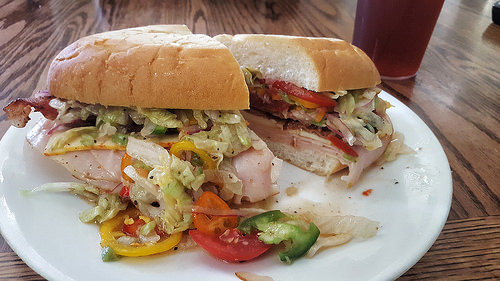<image>
Is the tomato above the meat? Yes. The tomato is positioned above the meat in the vertical space, higher up in the scene. 